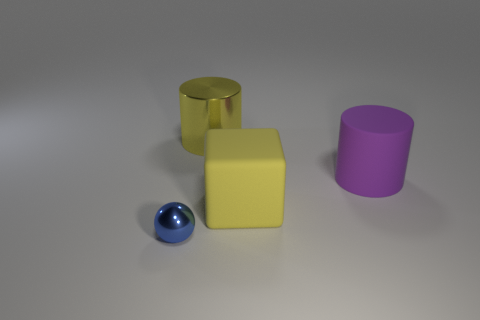Is the block the same color as the large metallic object?
Your answer should be very brief. Yes. Are there fewer big purple things behind the large purple rubber thing than big matte things?
Provide a short and direct response. Yes. Do the big purple cylinder and the big object that is in front of the rubber cylinder have the same material?
Keep it short and to the point. Yes. What material is the yellow block?
Offer a very short reply. Rubber. There is a yellow thing that is on the right side of the metal thing that is behind the blue metallic ball on the left side of the purple matte thing; what is its material?
Make the answer very short. Rubber. There is a metal cylinder; does it have the same color as the big rubber thing that is on the left side of the big purple thing?
Ensure brevity in your answer.  Yes. Are there any other things that have the same shape as the blue thing?
Your answer should be very brief. No. What is the color of the metallic object that is in front of the shiny thing that is behind the small blue sphere?
Provide a succinct answer. Blue. What number of red matte spheres are there?
Offer a terse response. 0. What number of rubber objects are purple cylinders or tiny gray blocks?
Your response must be concise. 1. 